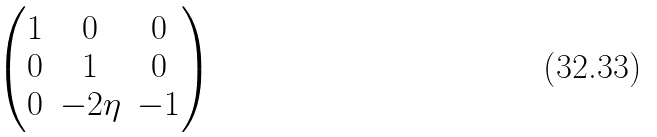<formula> <loc_0><loc_0><loc_500><loc_500>\begin{pmatrix} 1 & 0 & 0 \\ 0 & 1 & 0 \\ 0 & - 2 \eta & - 1 \end{pmatrix}</formula> 